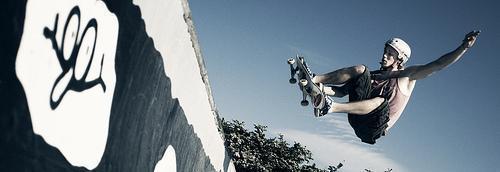How many skateboarders are wearing yellow helmets?
Give a very brief answer. 0. 